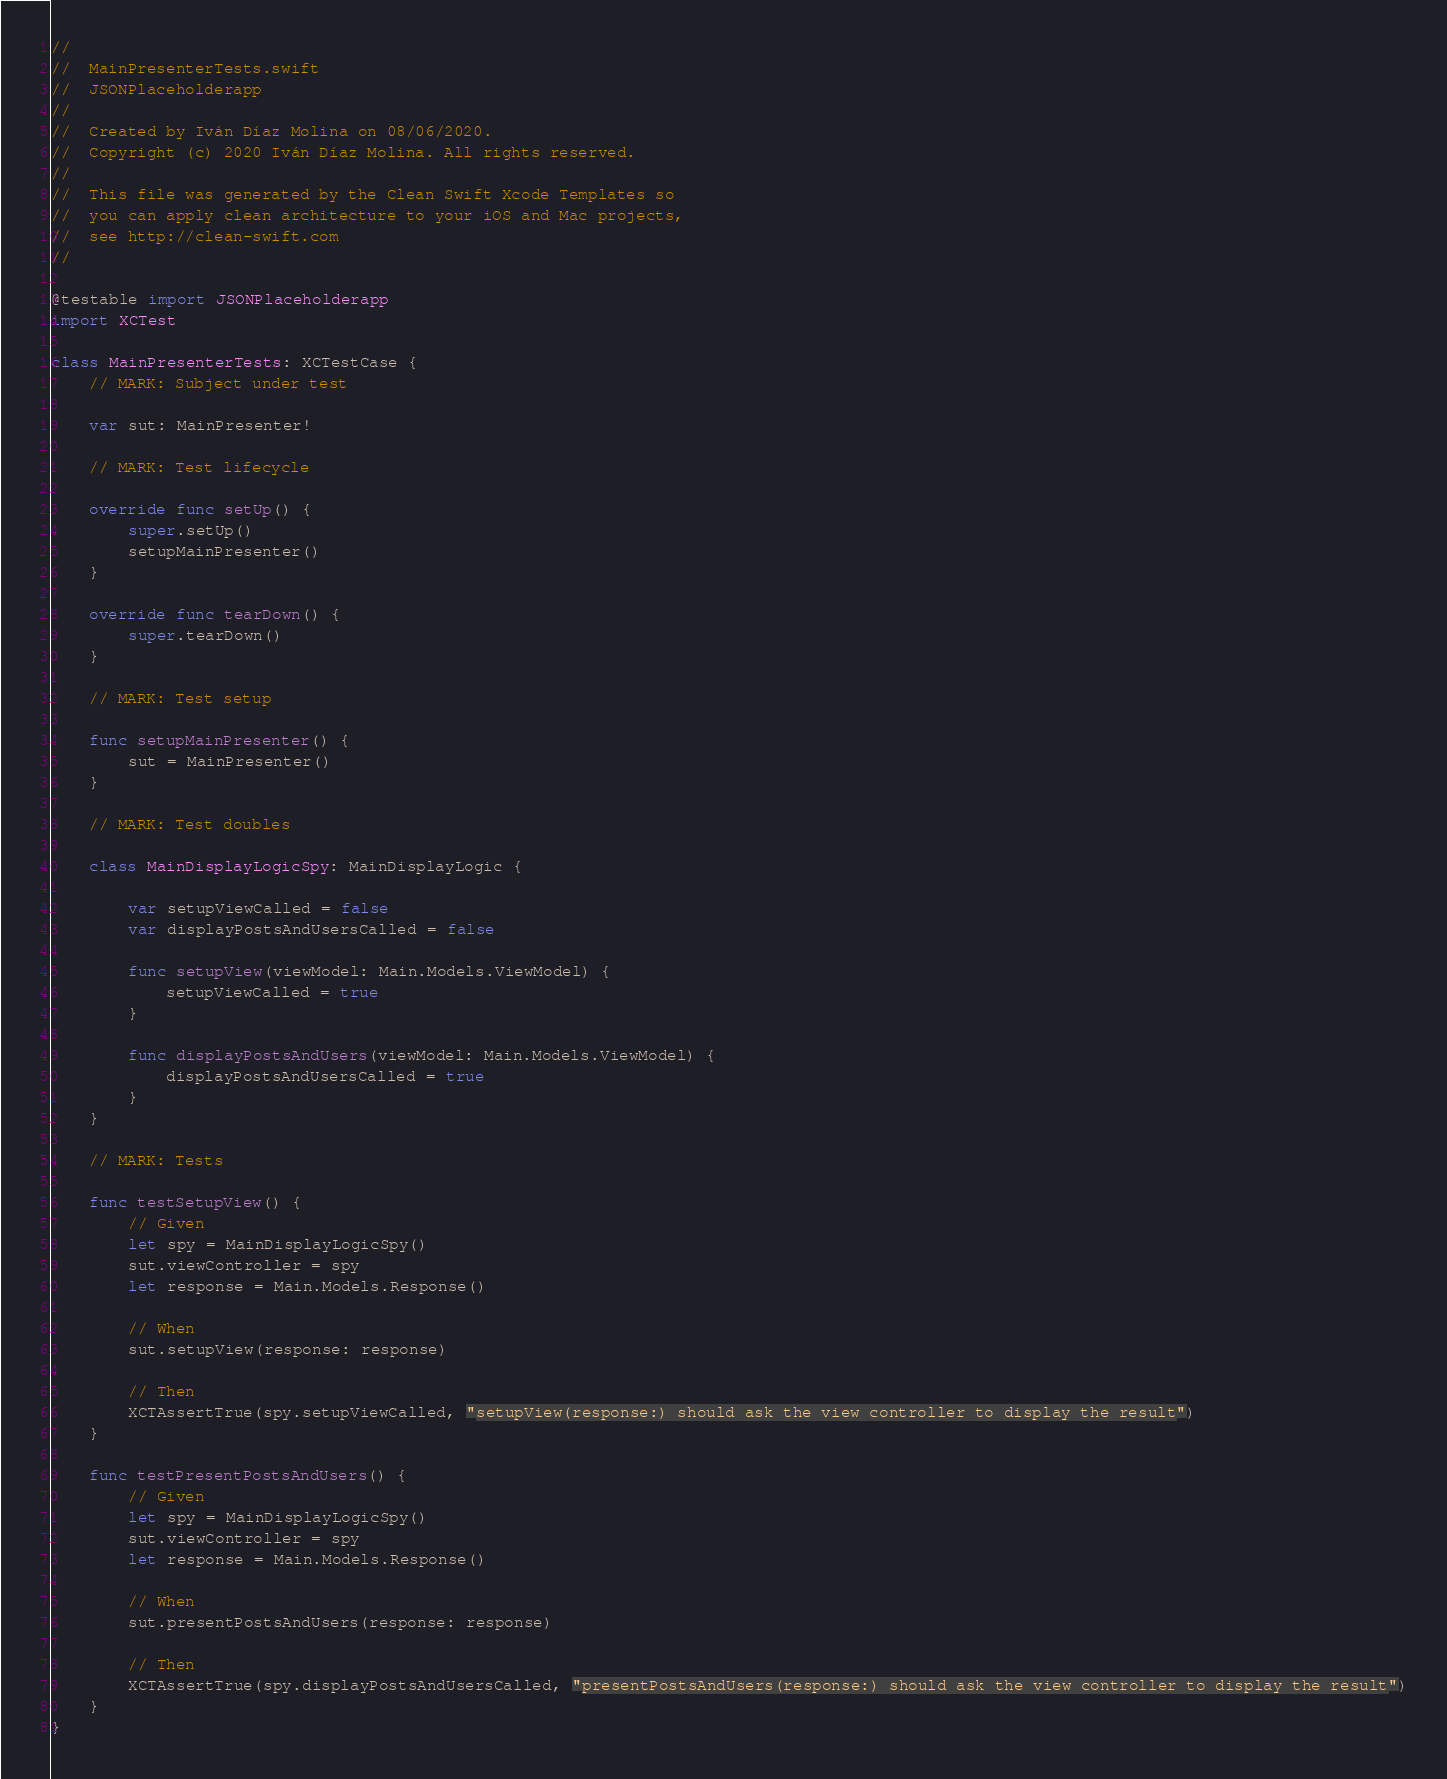Convert code to text. <code><loc_0><loc_0><loc_500><loc_500><_Swift_>//
//  MainPresenterTests.swift
//  JSONPlaceholderapp
//
//  Created by Iván Díaz Molina on 08/06/2020.
//  Copyright (c) 2020 Iván Díaz Molina. All rights reserved.
//
//  This file was generated by the Clean Swift Xcode Templates so
//  you can apply clean architecture to your iOS and Mac projects,
//  see http://clean-swift.com
//

@testable import JSONPlaceholderapp
import XCTest

class MainPresenterTests: XCTestCase {
    // MARK: Subject under test
    
    var sut: MainPresenter!
    
    // MARK: Test lifecycle
    
    override func setUp() {
        super.setUp()
        setupMainPresenter()
    }
    
    override func tearDown() {
        super.tearDown()
    }
    
    // MARK: Test setup
    
    func setupMainPresenter() {
        sut = MainPresenter()
    }
    
    // MARK: Test doubles
    
    class MainDisplayLogicSpy: MainDisplayLogic {
        
        var setupViewCalled = false
        var displayPostsAndUsersCalled = false
        
        func setupView(viewModel: Main.Models.ViewModel) {
            setupViewCalled = true
        }
        
        func displayPostsAndUsers(viewModel: Main.Models.ViewModel) {
            displayPostsAndUsersCalled = true
        }
    }
    
    // MARK: Tests
    
    func testSetupView() {
        // Given
        let spy = MainDisplayLogicSpy()
        sut.viewController = spy
        let response = Main.Models.Response()
        
        // When
        sut.setupView(response: response)
        
        // Then
        XCTAssertTrue(spy.setupViewCalled, "setupView(response:) should ask the view controller to display the result")
    }
    
    func testPresentPostsAndUsers() {
        // Given
        let spy = MainDisplayLogicSpy()
        sut.viewController = spy
        let response = Main.Models.Response()
        
        // When
        sut.presentPostsAndUsers(response: response)
        
        // Then
        XCTAssertTrue(spy.displayPostsAndUsersCalled, "presentPostsAndUsers(response:) should ask the view controller to display the result")
    }
}
</code> 